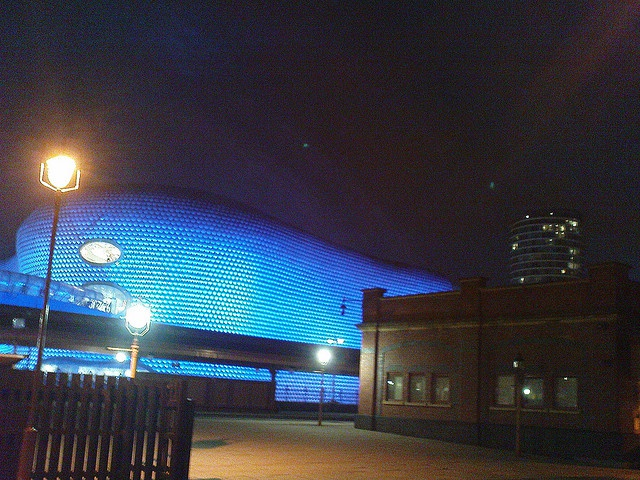Describe the objects in this image and their specific colors. I can see various objects in this image with different colors. 